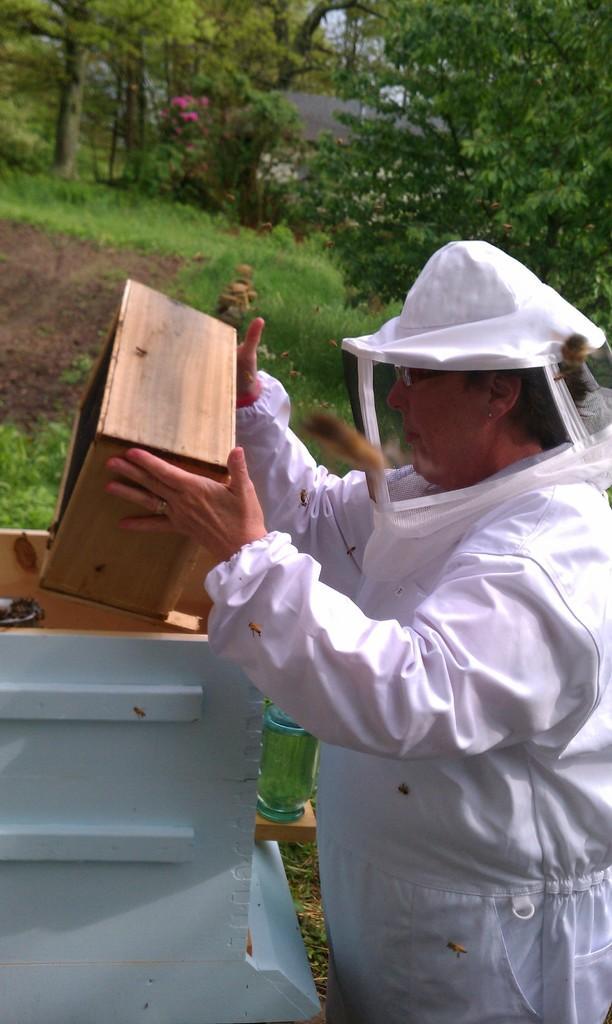Can you describe this image briefly? In the picture there is a man, he is catching a box, there are bees, there are trees, there is grass present. 